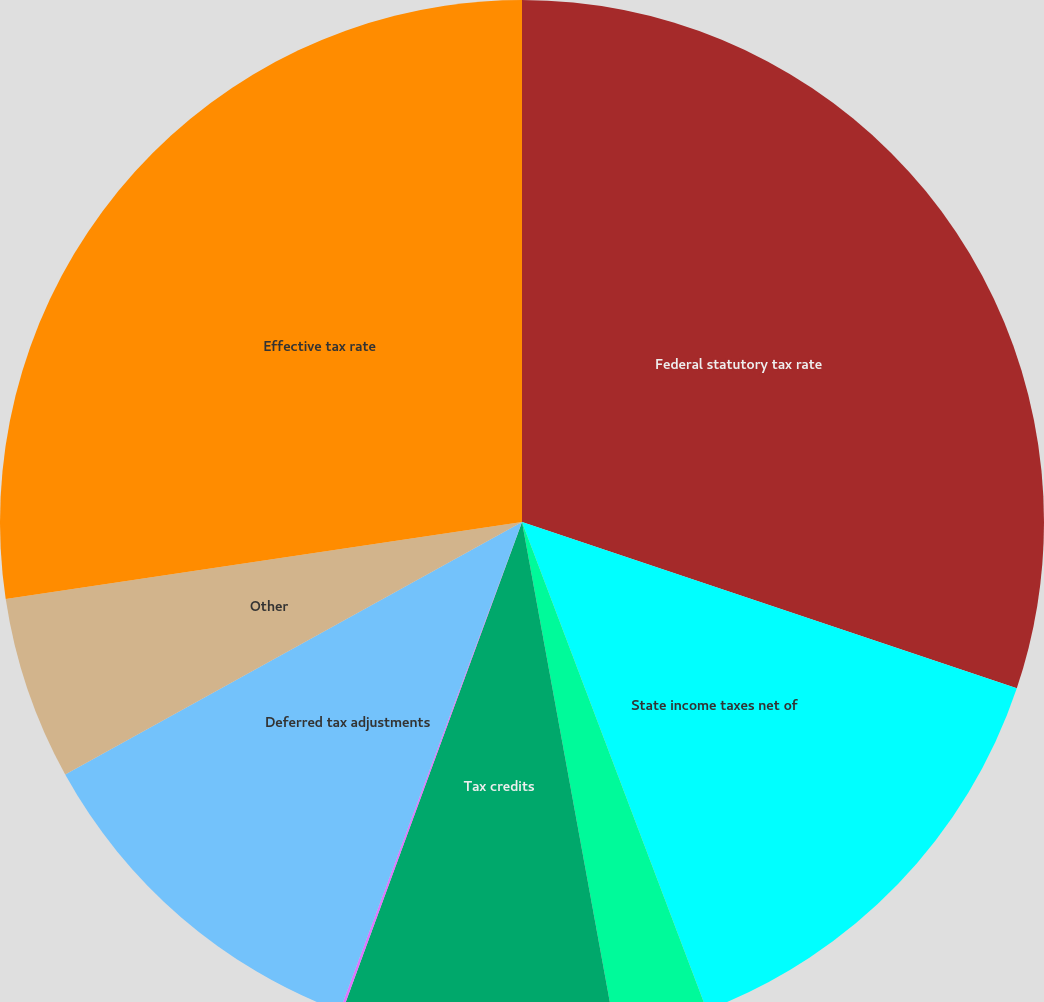<chart> <loc_0><loc_0><loc_500><loc_500><pie_chart><fcel>Federal statutory tax rate<fcel>State income taxes net of<fcel>Disallowed executive<fcel>Tax credits<fcel>Estimated reserve for<fcel>Deferred tax adjustments<fcel>Other<fcel>Effective tax rate<nl><fcel>30.16%<fcel>14.08%<fcel>2.88%<fcel>8.48%<fcel>0.08%<fcel>11.28%<fcel>5.68%<fcel>27.36%<nl></chart> 